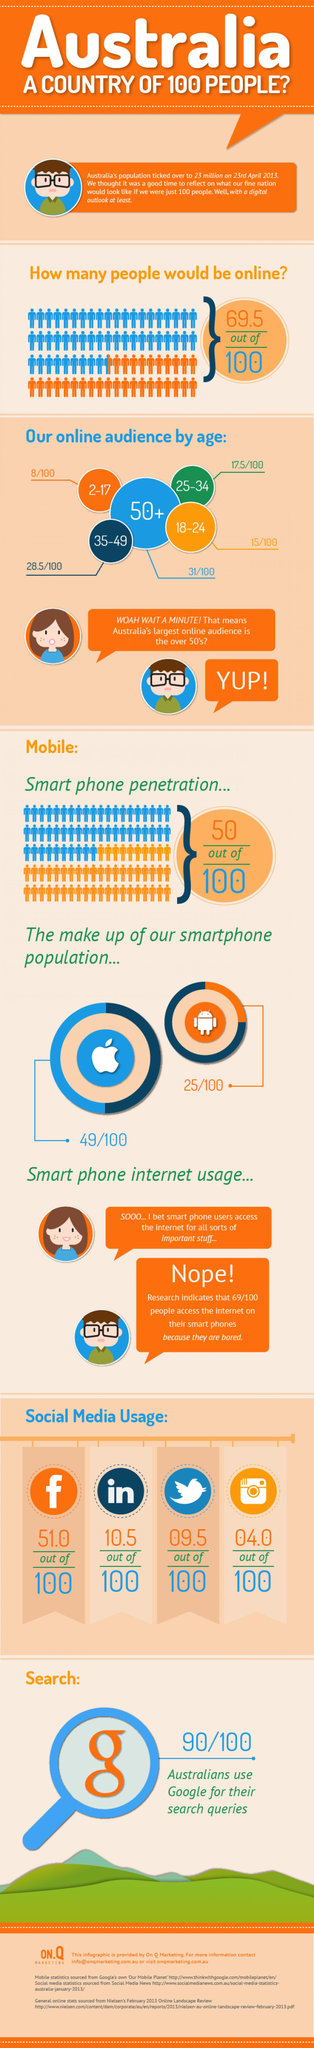Outline some significant characteristics in this image. Ninety-five percent of 100 people use Twitter. The age group with the smallest number of online users is 2-17 years old. According to a recent survey, 51% of people use Facebook. In a study, it was found that out of 100 people, 10.5 use LinkedIn. According to the data, 28.5% of the online audience belongs to the age group of 35-49. 